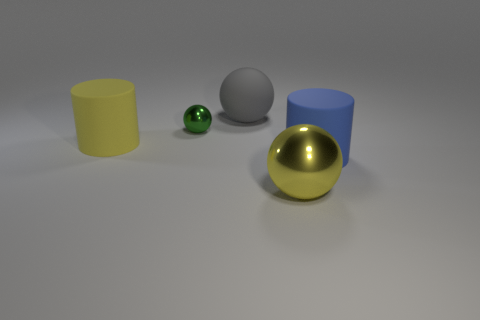What number of objects are cyan metallic objects or big matte objects?
Ensure brevity in your answer.  3. Are there any gray objects that have the same size as the green metal sphere?
Offer a terse response. No. What is the shape of the tiny object?
Your answer should be very brief. Sphere. Is the number of green metal things in front of the big yellow sphere greater than the number of cylinders in front of the large blue object?
Your response must be concise. No. Do the big rubber object in front of the yellow rubber thing and the tiny ball that is in front of the gray object have the same color?
Give a very brief answer. No. There is a blue rubber object that is the same size as the yellow sphere; what is its shape?
Keep it short and to the point. Cylinder. Are there any other big things of the same shape as the big blue thing?
Make the answer very short. Yes. Does the large cylinder right of the gray ball have the same material as the large object that is in front of the blue object?
Offer a very short reply. No. The large matte object that is the same color as the large shiny thing is what shape?
Your response must be concise. Cylinder. What number of things are the same material as the small green sphere?
Give a very brief answer. 1. 